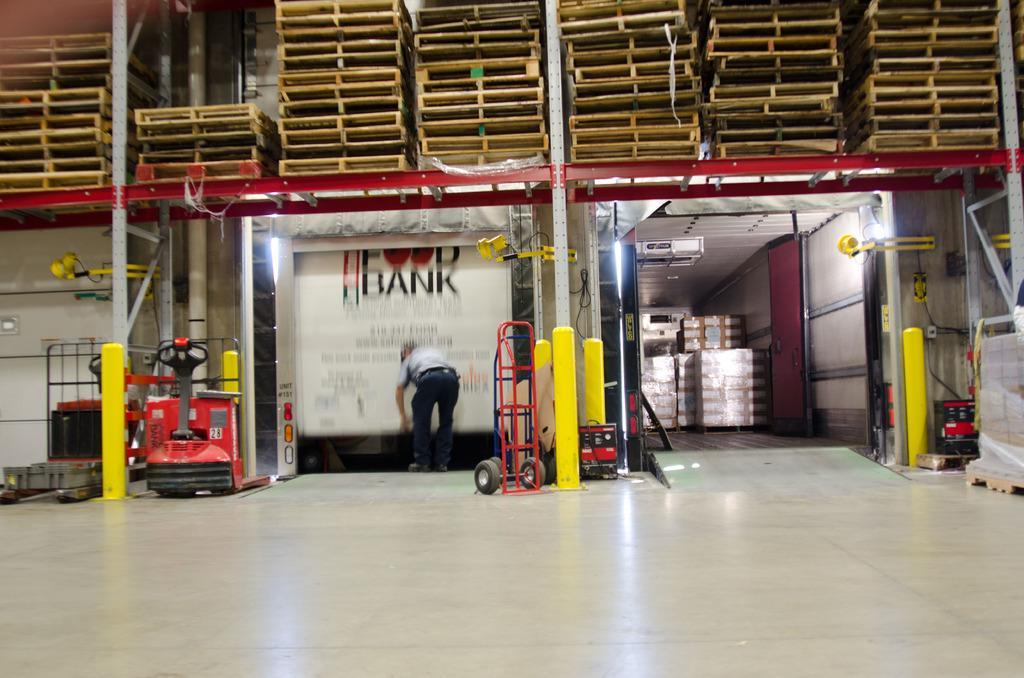In one or two sentences, can you explain what this image depicts? In this picture I can see a man is standing on the floor. In the background I can see a wall, some machines, poles and other objects. I can also see some boxes. 